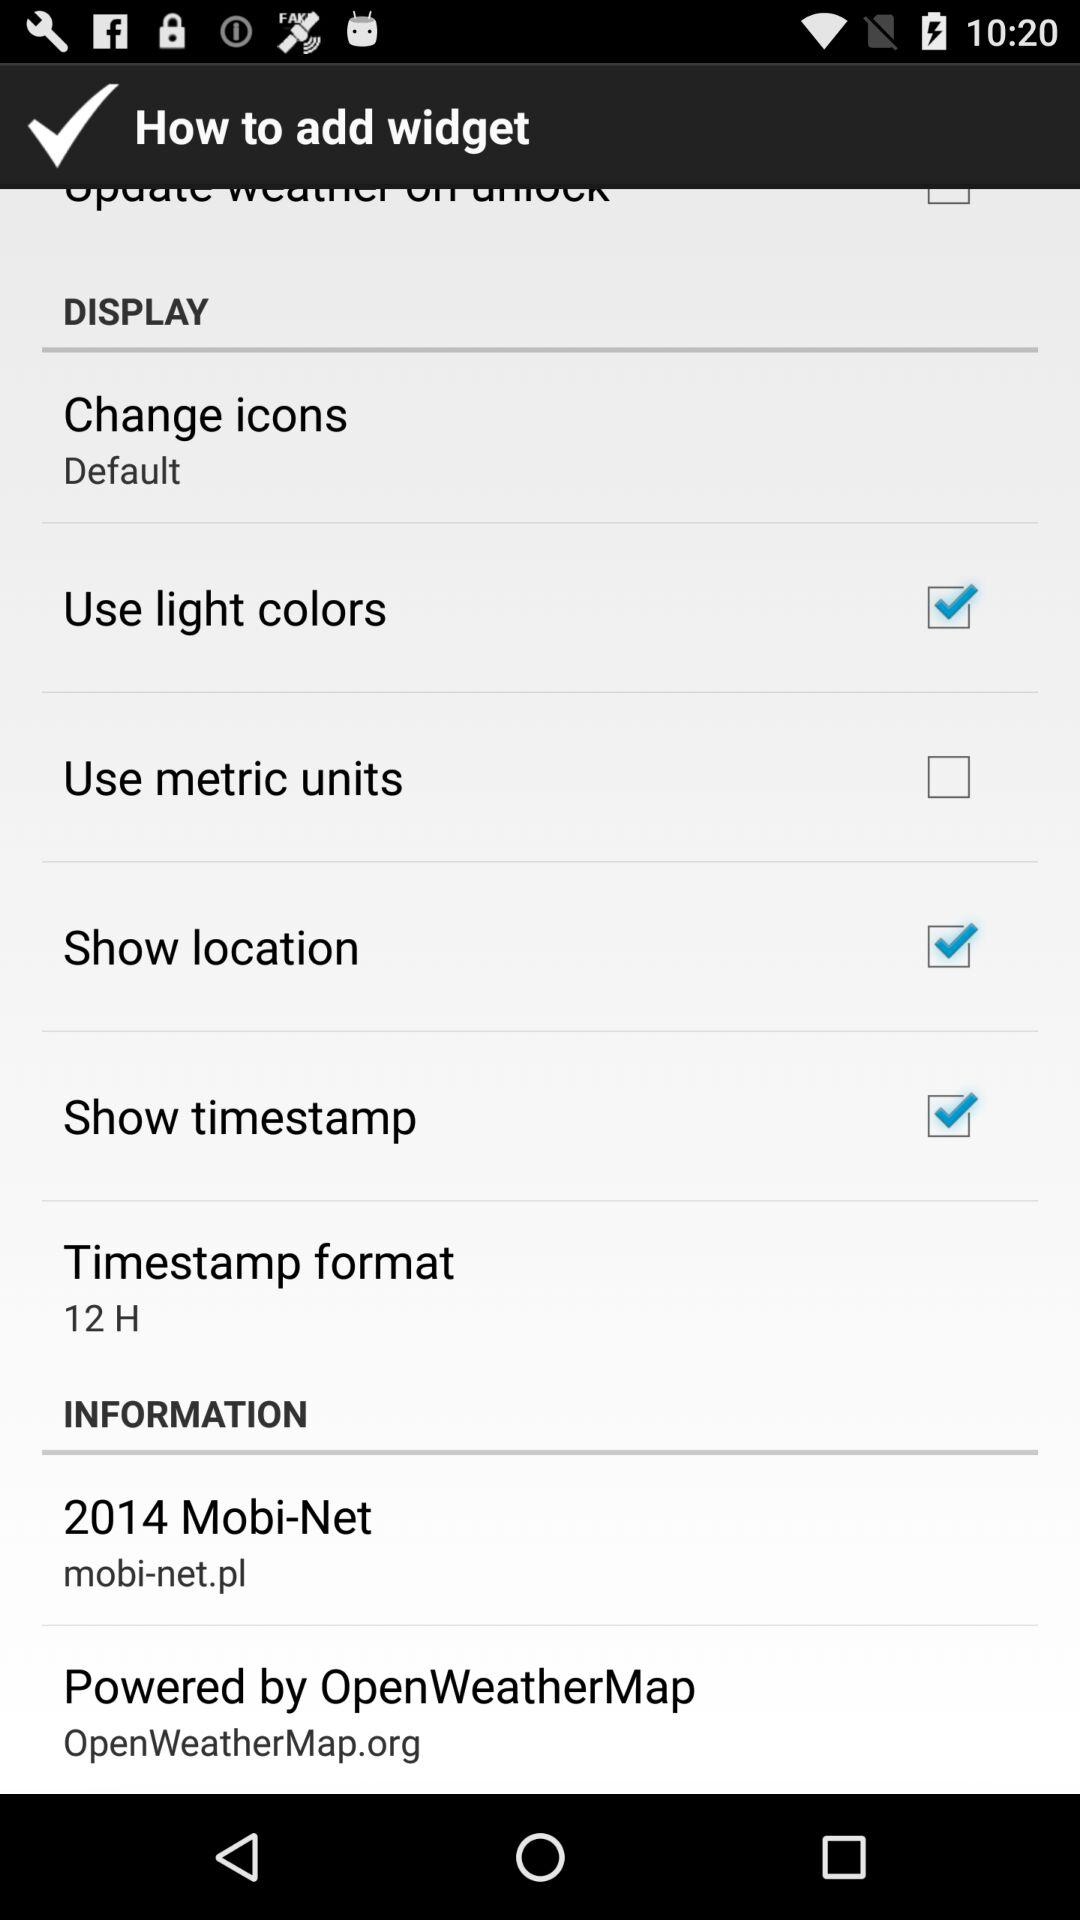What is the status of "Show location"? The status of "Show location" is "on". 